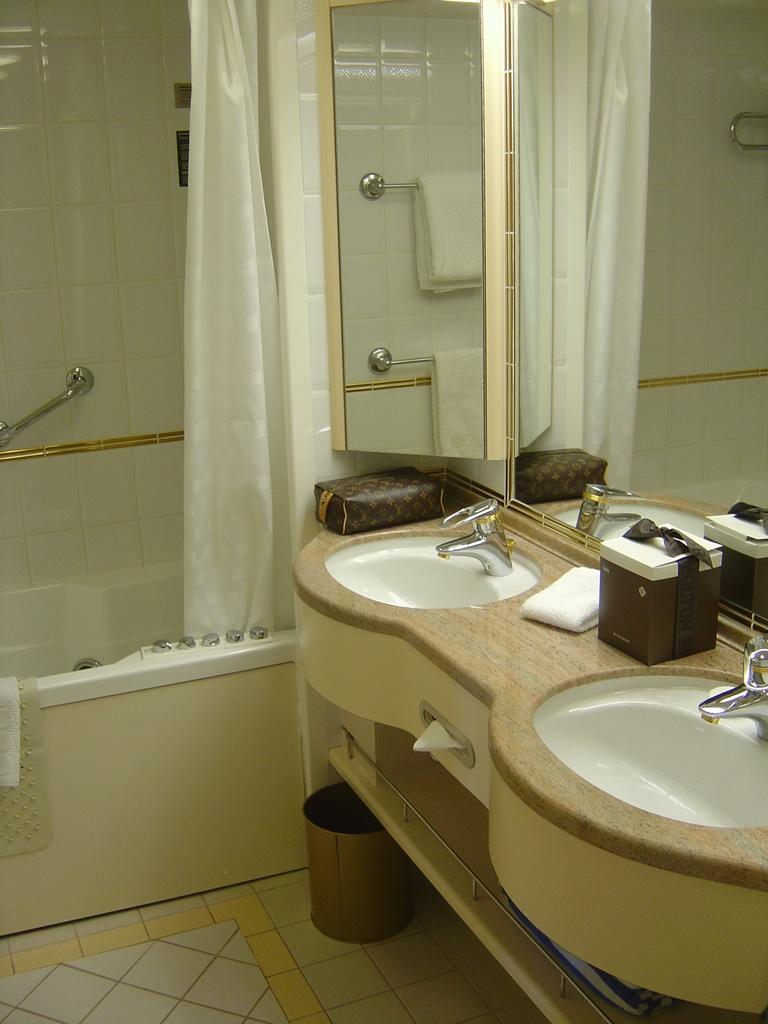In one or two sentences, can you explain what this image depicts? In this image we can sinks, taps, tissue papers, objects on the sink, curtain, mirrors, bath tub, shower and dustbin on the floor. 